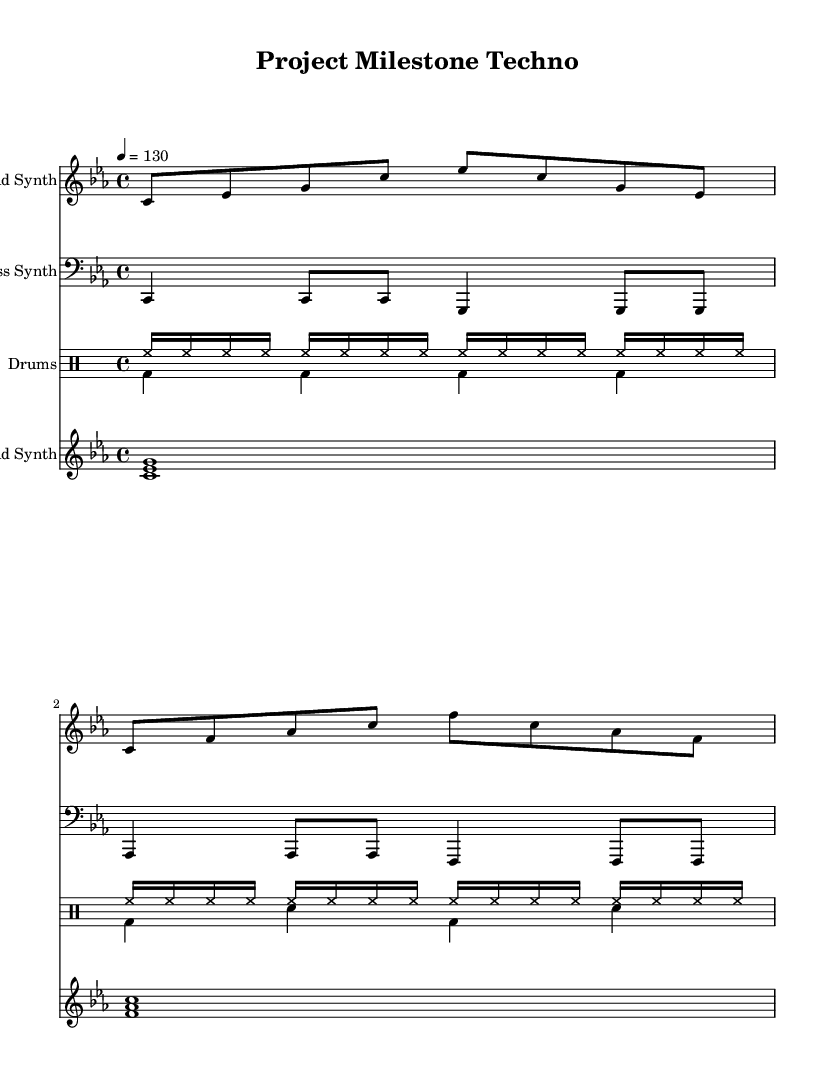What is the key signature of this music? The key signature is C minor, which has three flats (B flat, E flat, and A flat). This can be determined from the \key command in the global section of the code.
Answer: C minor What is the time signature of this music? The time signature is 4/4. This is indicated by the \time command in the global section of the code, which defines how many beats are in each measure.
Answer: 4/4 What is the tempo marking of this music? The tempo marking is 130 beats per minute. This is indicated by the \tempo command in the global section, reflecting the speed at which the piece should be played.
Answer: 130 How many measures are in the lead synth section? There are 8 measures in the lead synth section, as each line has two measures and there are four lines present in the lead section.
Answer: 8 What note values are predominantly used in the drums up section? The predominant note value used in the drums up section is sixteenth notes, as shown by the hihat16 notation repeated multiple times throughout.
Answer: sixteenth notes What is the duration of the chord played in the pad synth section? The duration of the chord played in the pad synth section is one whole note (1), indicating that each chord is held for the entire measure.
Answer: whole note Which instruments are included in this piece? The instruments included are lead synth, bass synth, drums, and pad synth, each specified in their respective staff section of the code.
Answer: lead synth, bass synth, drums, pad synth 